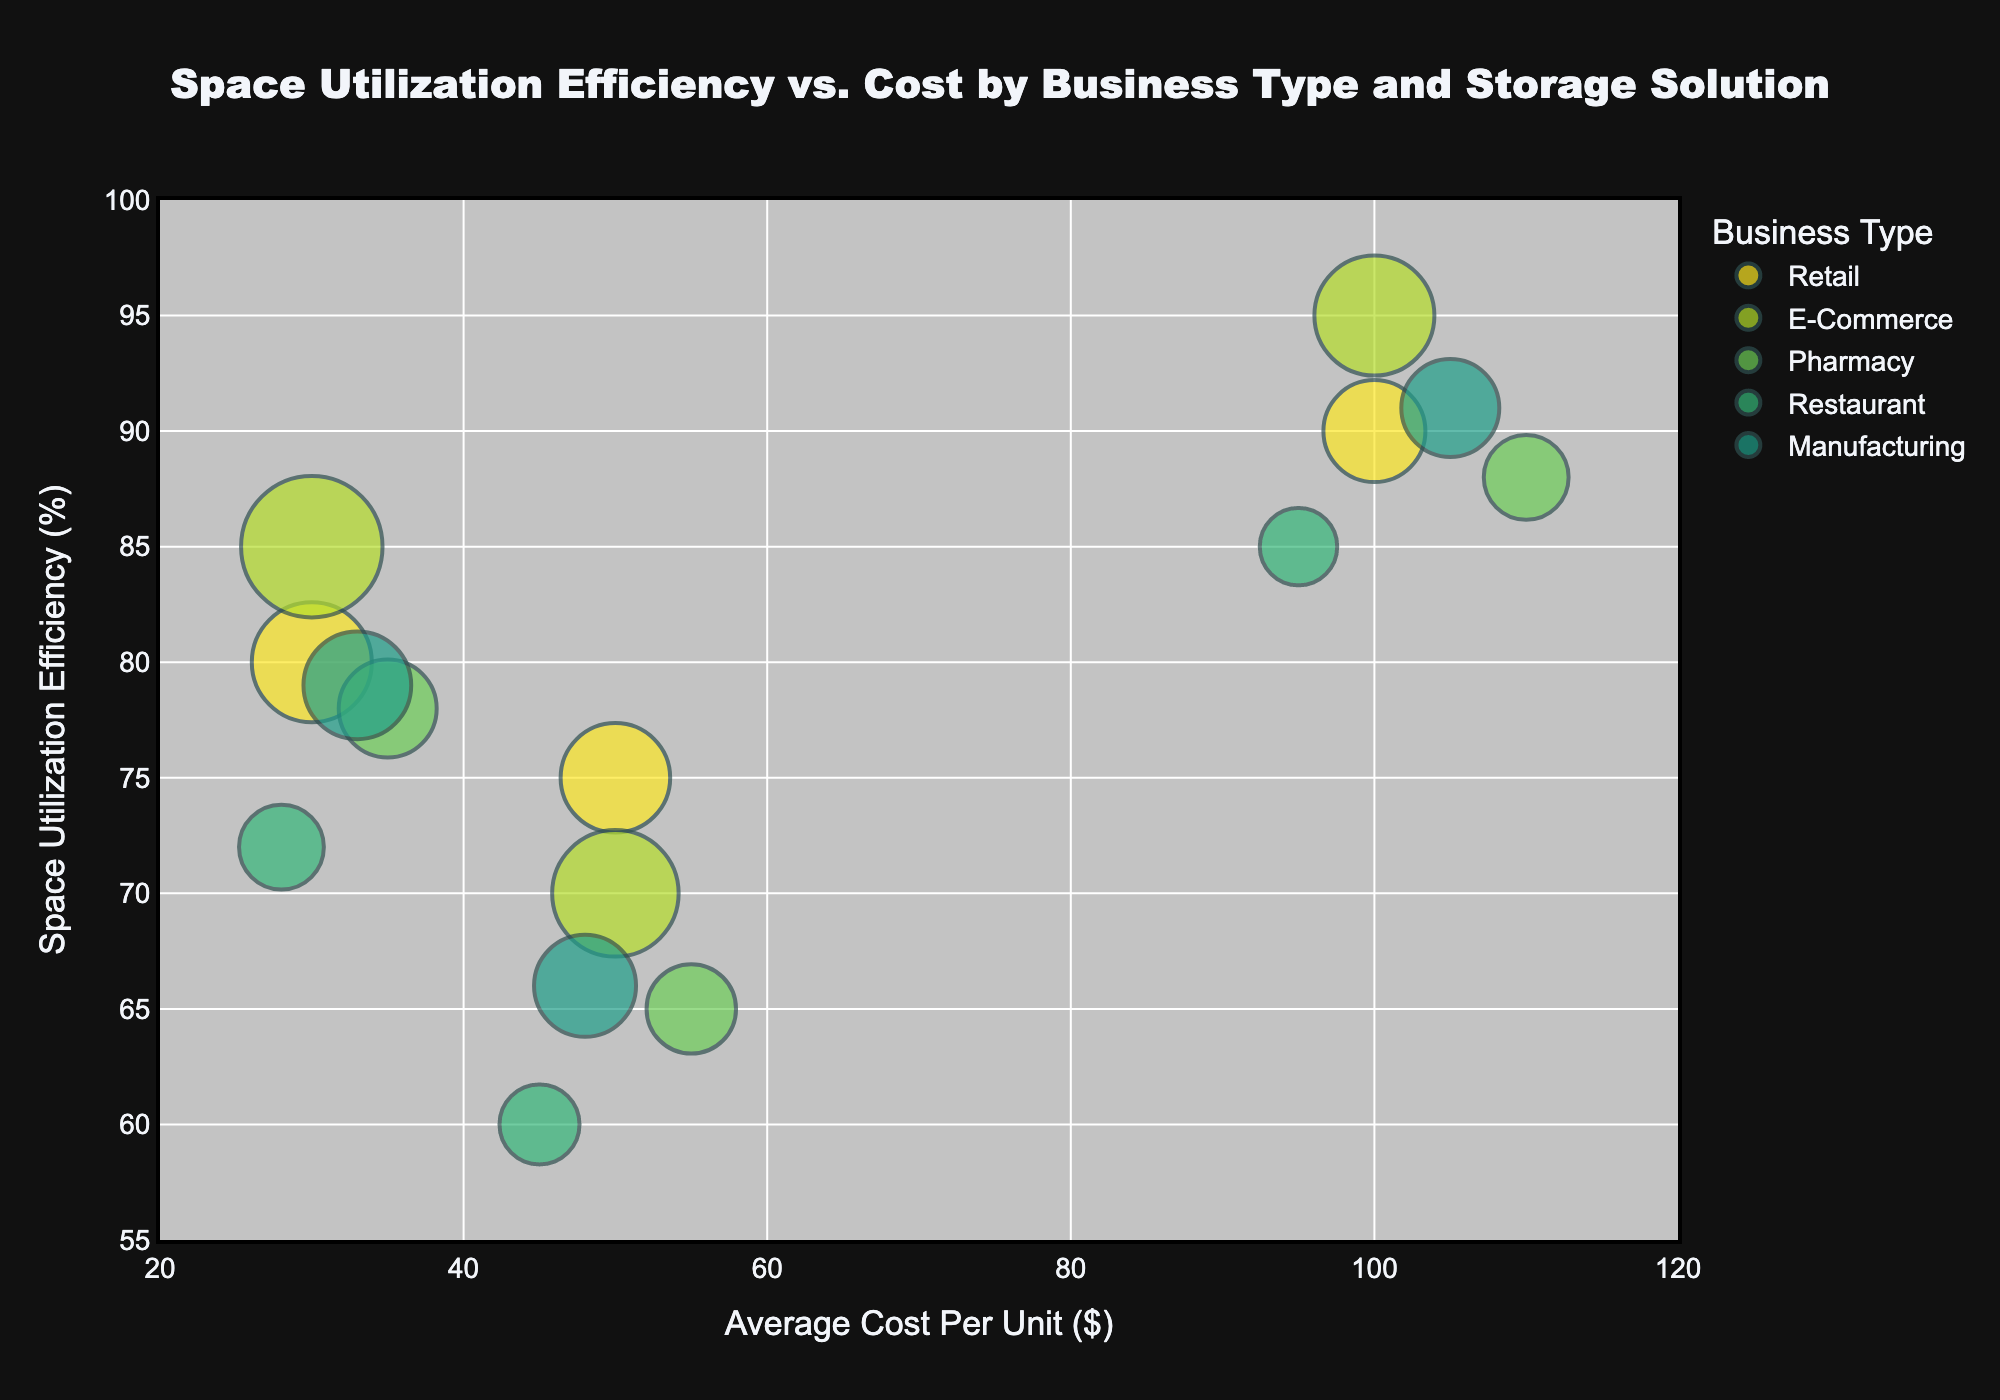what is the title of the figure? The title of the figure is displayed prominently at the top. It's centered with a larger font size than other text elements, making it easy to identify.
Answer: Space Utilization Efficiency vs. Cost by Business Type and Storage Solution What is the average cost per unit for the Heavy-Duty Shelving in the Manufacturing sector? Locate the bubble for Heavy-Duty Shelving under the Manufacturing business type by checking the color and label when hovering over the bubble. Identify its position on the x-axis, representing the Average Cost Per Unit.
Answer: $105 Which business type has a storage solution with the highest space utilization efficiency, and what is that efficiency? Identify the bubble that is highest on the y-axis (Space Utilization Efficiency). Hover over or check the color to find the business type. Note the efficiency value from the y-axis.
Answer: E-Commerce, 95% How many bubbles represent storage solutions for the Retail sector? Identify the color associated with the Retail business type in the legend. Count the number of bubbles in that color.
Answer: 3 Between Plastic Bins and Wire Shelving, which storage solution has better space utilization efficiency for Restaurants? Locate the bubbles for Restaurants based on their color. Compare the y-axis positions of the Plastic Bins and Wire Shelving bubbles. Higher y-axis value indicates better efficiency.
Answer: Plastic Bins What is the difference in space utilization efficiency between the most efficient and least efficient storage solutions for Pharmacies? Identify the highest and lowest points on the y-axis for bubbles labeled Pharmacy. Note their efficiency values and subtract the lower value from the higher value.
Answer: 23% In which business type is the storage solution with the highest number of units used? Identify the largest bubble by size on the chart and hover over it to determine the business type from the hover information.
Answer: E-Commerce Which storage solution in the Manufacturing sector is the most cost-effective per unit while having a space utilization efficiency of at least 70%? Filter to the Manufacturing sector by checking the color. Look at bubbles with a y-axis value of at least 70%. Compare their x-axis values to find the smallest one.
Answer: Plastic Bins What is the average space utilization efficiency for Wire Shelving across all business types? Identify and record the y-axis values of all bubbles labeled as Wire Shelving. Sum these values and divide by the number of Wire Shelving bubbles to find their average.
Answer: 67.2% How does the space utilization efficiency of Plastic Bins in the Retail sector compare to that in the E-Commerce sector? Find the Plastic Bins bubbles for both Retail and E-Commerce by matching colors and labels. Compare their y-axis positions to see which is higher.
Answer: E-Commerce is higher 